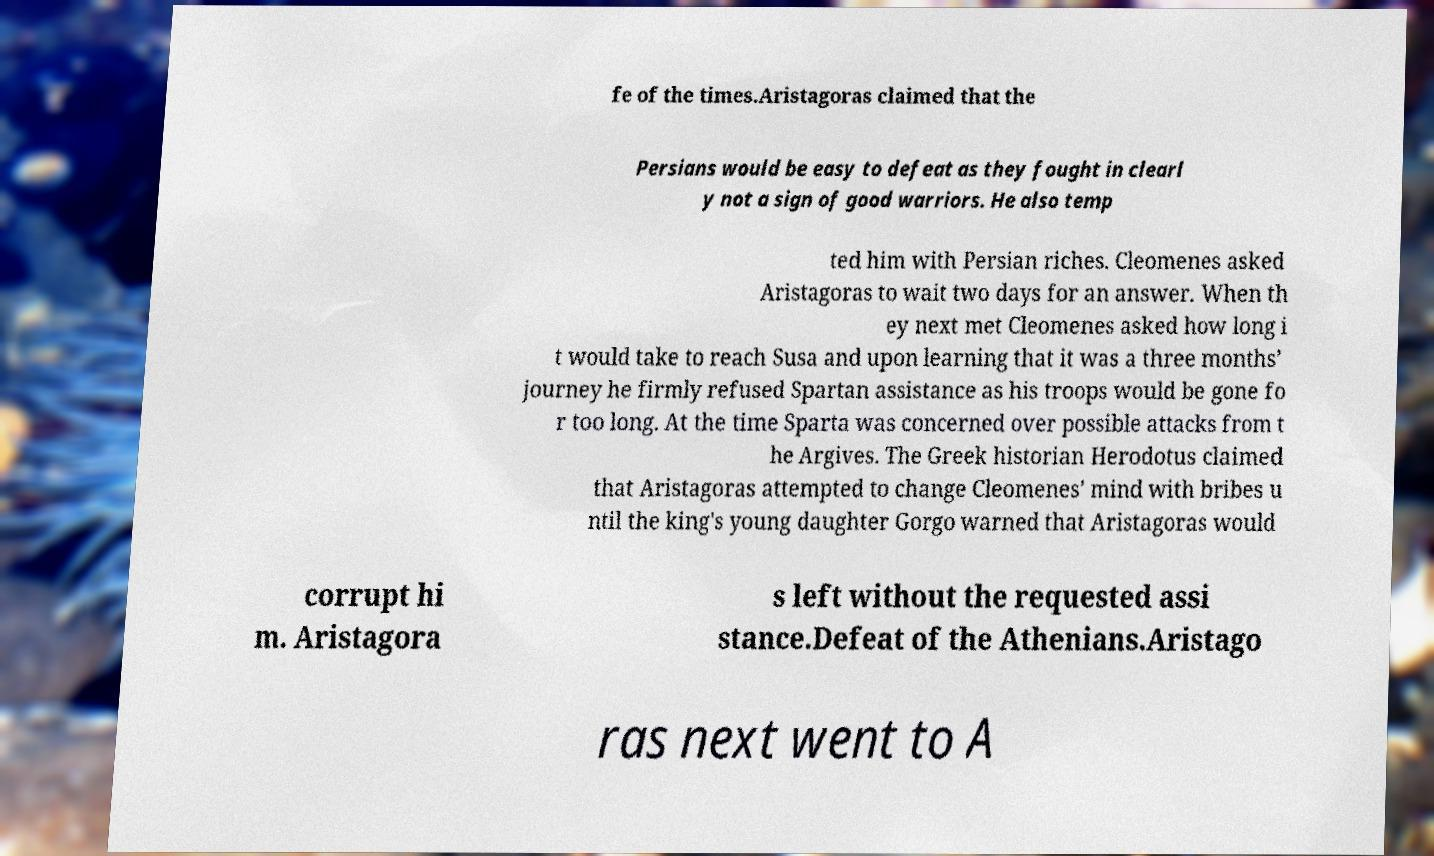Please read and relay the text visible in this image. What does it say? fe of the times.Aristagoras claimed that the Persians would be easy to defeat as they fought in clearl y not a sign of good warriors. He also temp ted him with Persian riches. Cleomenes asked Aristagoras to wait two days for an answer. When th ey next met Cleomenes asked how long i t would take to reach Susa and upon learning that it was a three months’ journey he firmly refused Spartan assistance as his troops would be gone fo r too long. At the time Sparta was concerned over possible attacks from t he Argives. The Greek historian Herodotus claimed that Aristagoras attempted to change Cleomenes’ mind with bribes u ntil the king's young daughter Gorgo warned that Aristagoras would corrupt hi m. Aristagora s left without the requested assi stance.Defeat of the Athenians.Aristago ras next went to A 